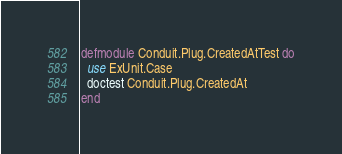Convert code to text. <code><loc_0><loc_0><loc_500><loc_500><_Elixir_>defmodule Conduit.Plug.CreatedAtTest do
  use ExUnit.Case
  doctest Conduit.Plug.CreatedAt
end
</code> 